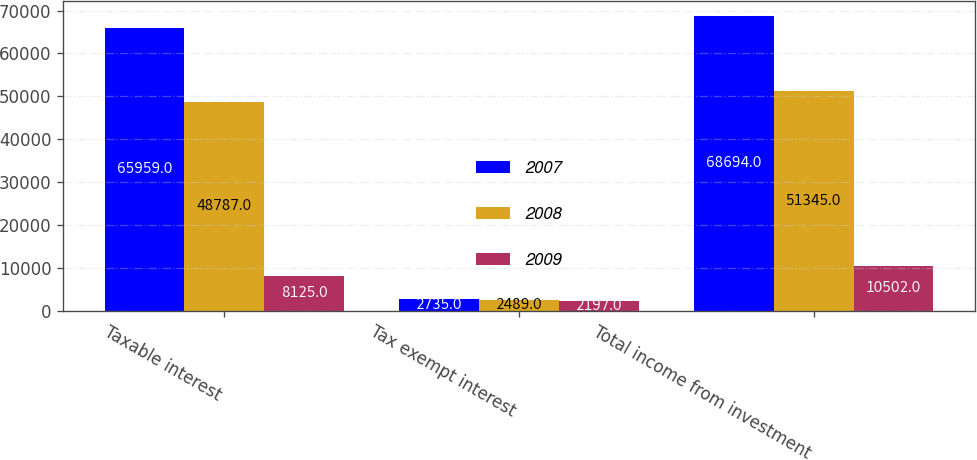<chart> <loc_0><loc_0><loc_500><loc_500><stacked_bar_chart><ecel><fcel>Taxable interest<fcel>Tax exempt interest<fcel>Total income from investment<nl><fcel>2007<fcel>65959<fcel>2735<fcel>68694<nl><fcel>2008<fcel>48787<fcel>2489<fcel>51345<nl><fcel>2009<fcel>8125<fcel>2197<fcel>10502<nl></chart> 